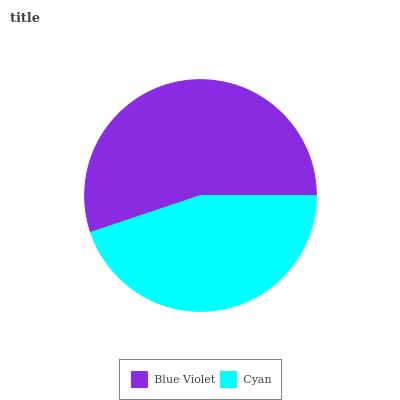Is Cyan the minimum?
Answer yes or no. Yes. Is Blue Violet the maximum?
Answer yes or no. Yes. Is Cyan the maximum?
Answer yes or no. No. Is Blue Violet greater than Cyan?
Answer yes or no. Yes. Is Cyan less than Blue Violet?
Answer yes or no. Yes. Is Cyan greater than Blue Violet?
Answer yes or no. No. Is Blue Violet less than Cyan?
Answer yes or no. No. Is Blue Violet the high median?
Answer yes or no. Yes. Is Cyan the low median?
Answer yes or no. Yes. Is Cyan the high median?
Answer yes or no. No. Is Blue Violet the low median?
Answer yes or no. No. 